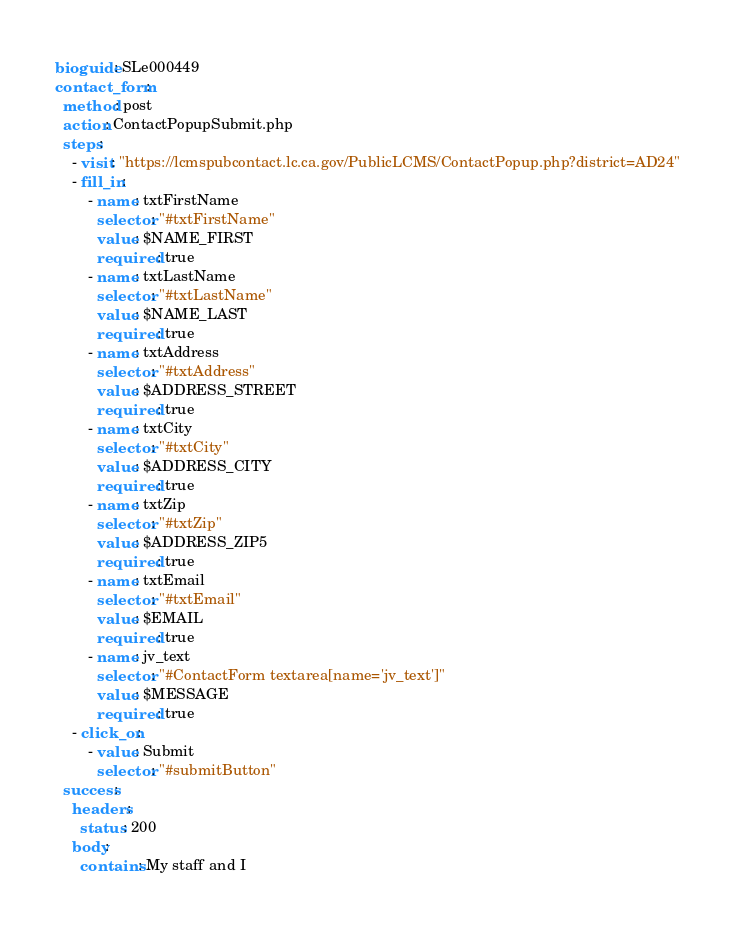Convert code to text. <code><loc_0><loc_0><loc_500><loc_500><_YAML_>bioguide: SLe000449
contact_form:
  method: post
  action: ContactPopupSubmit.php
  steps:
    - visit: "https://lcmspubcontact.lc.ca.gov/PublicLCMS/ContactPopup.php?district=AD24"
    - fill_in:
        - name: txtFirstName
          selector: "#txtFirstName"
          value: $NAME_FIRST
          required: true
        - name: txtLastName
          selector: "#txtLastName"
          value: $NAME_LAST
          required: true
        - name: txtAddress
          selector: "#txtAddress"
          value: $ADDRESS_STREET
          required: true
        - name: txtCity
          selector: "#txtCity"
          value: $ADDRESS_CITY
          required: true
        - name: txtZip
          selector: "#txtZip"
          value: $ADDRESS_ZIP5
          required: true
        - name: txtEmail
          selector: "#txtEmail"
          value: $EMAIL
          required: true
        - name: jv_text
          selector: "#ContactForm textarea[name='jv_text']"
          value: $MESSAGE
          required: true
    - click_on:
        - value: Submit
          selector: "#submitButton"
  success:
    headers:
      status: 200
    body:
      contains: My staff and I
</code> 